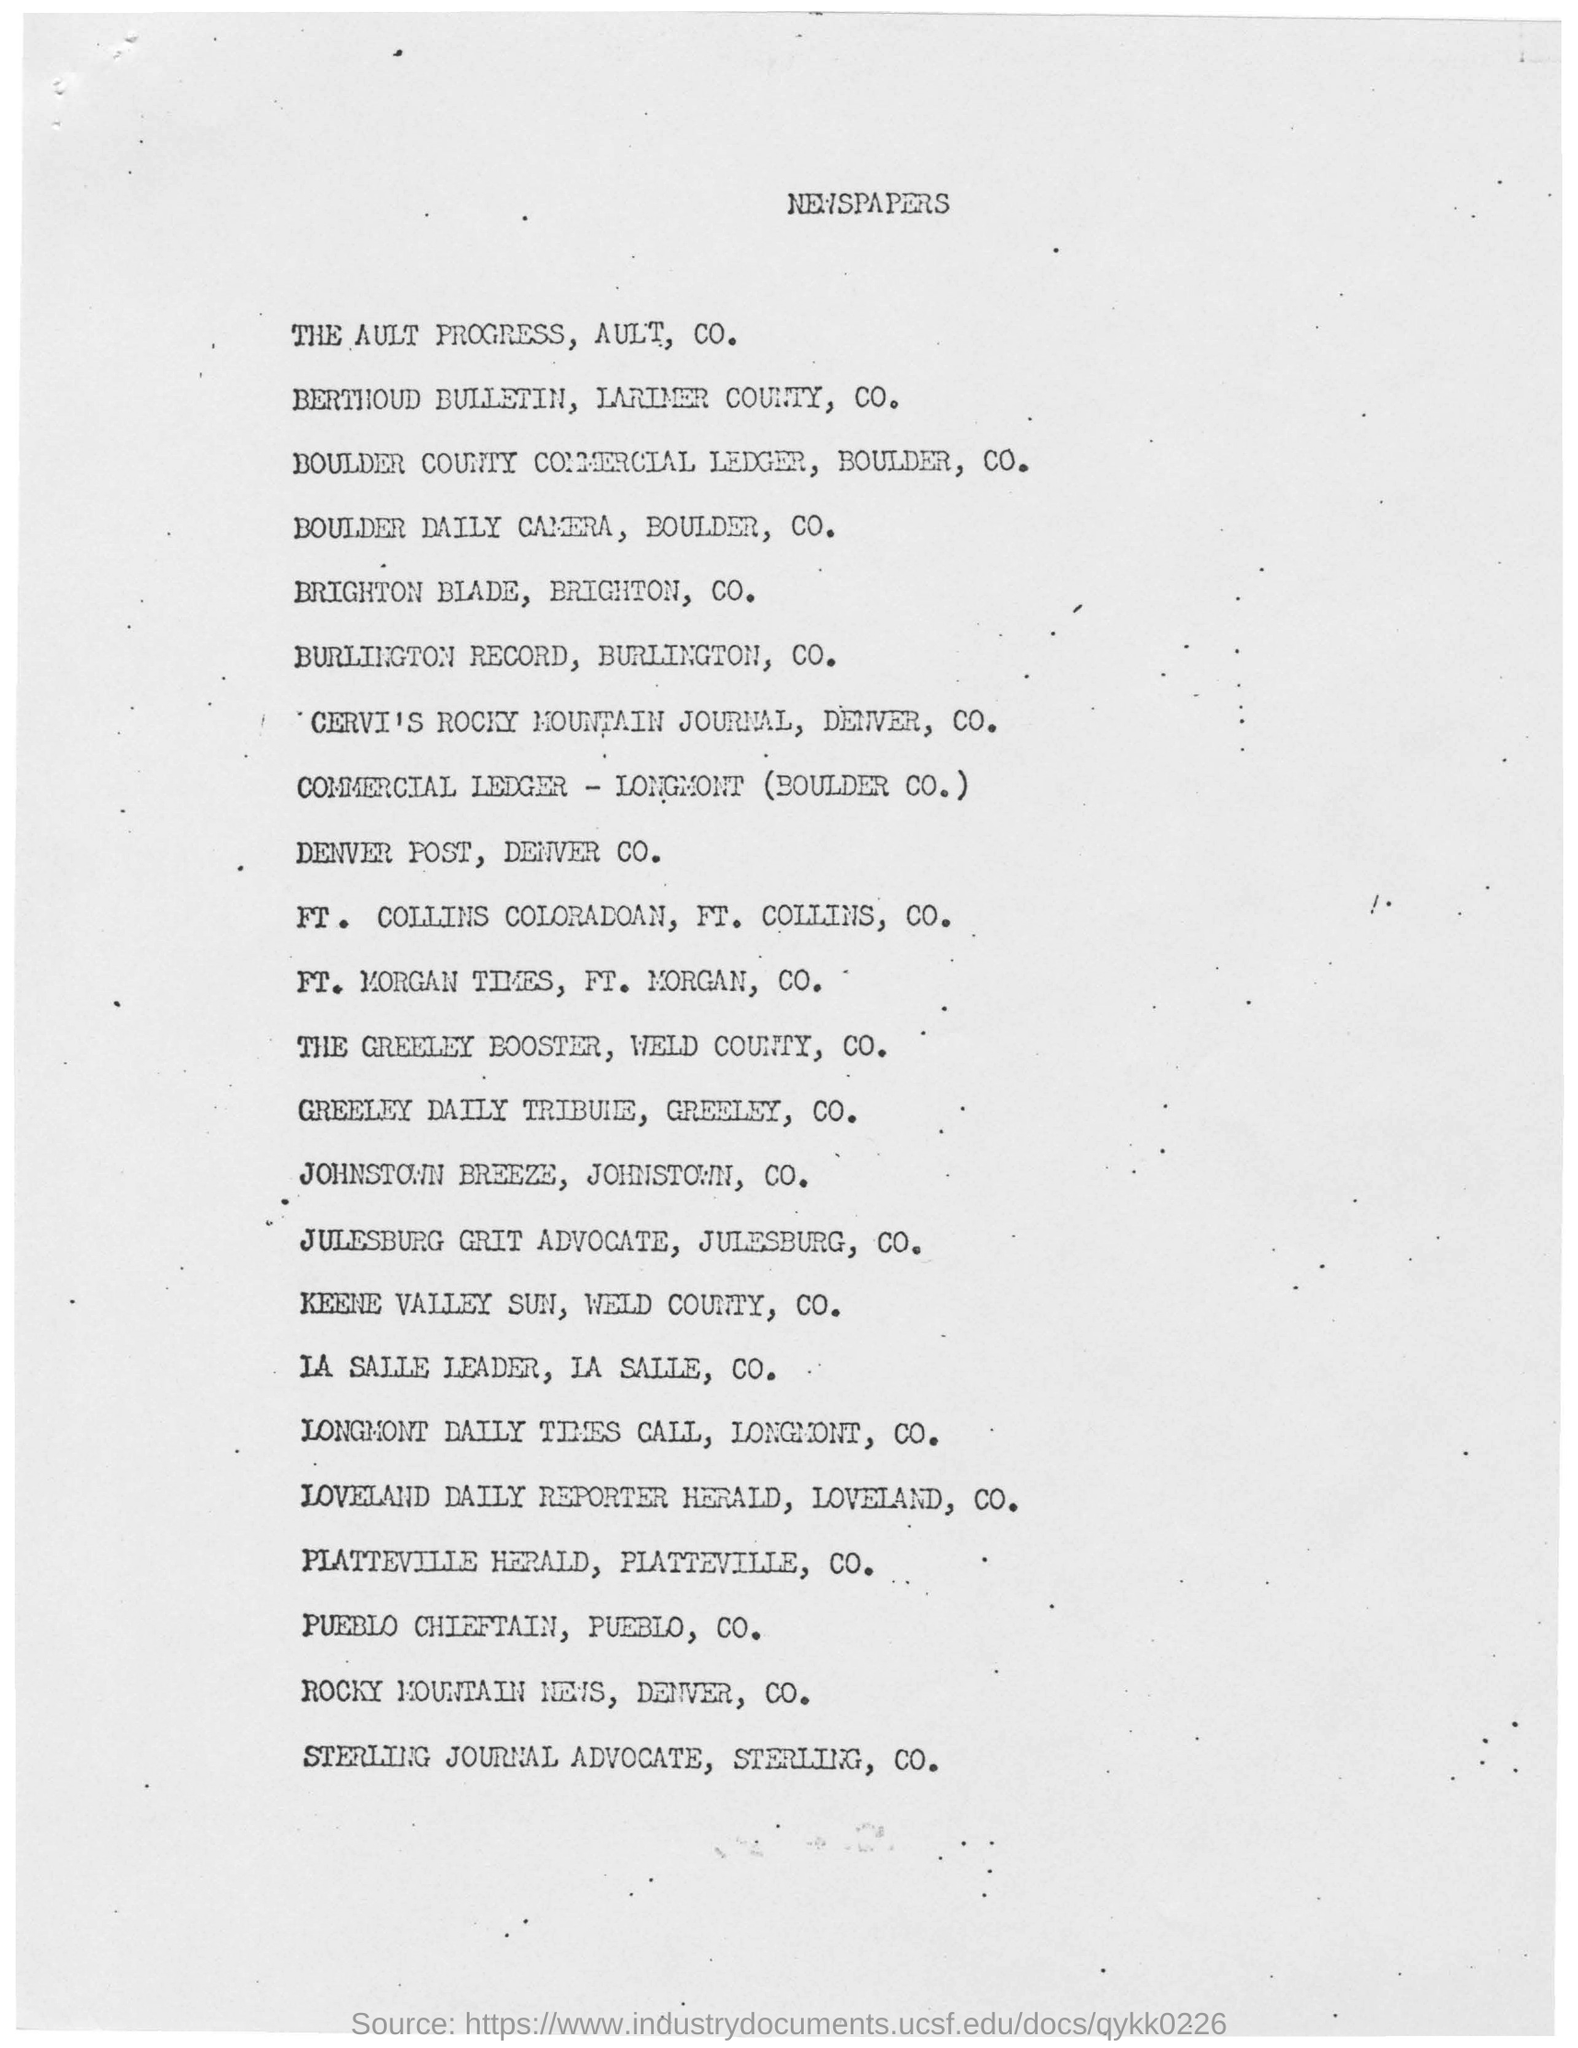What is the Head line of the document?
Your answer should be compact. Newspapers. 